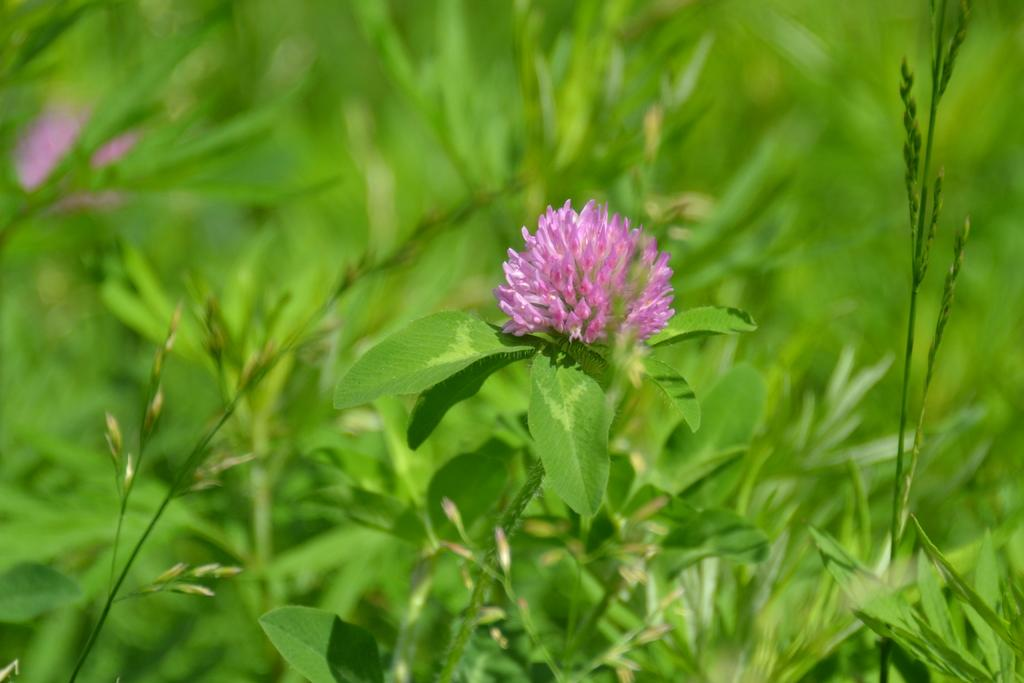What is the main subject of the image? There is a flower in the image. Where is the flower located? The flower is on a plant. What else can be seen in the background of the image? There are plants in the background of the image. How many dimes can be seen on the plant next to the flower in the image? There are no dimes present in the image; it only features a flower on a plant and plants in the background. 